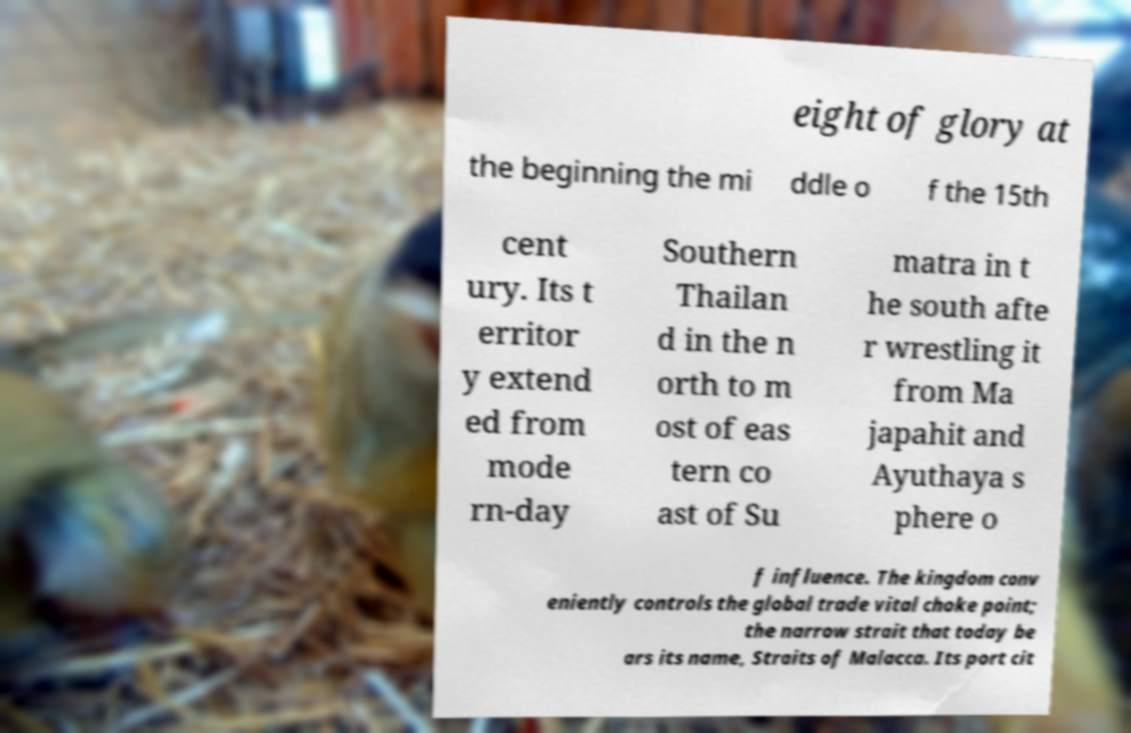Can you read and provide the text displayed in the image?This photo seems to have some interesting text. Can you extract and type it out for me? eight of glory at the beginning the mi ddle o f the 15th cent ury. Its t erritor y extend ed from mode rn-day Southern Thailan d in the n orth to m ost of eas tern co ast of Su matra in t he south afte r wrestling it from Ma japahit and Ayuthaya s phere o f influence. The kingdom conv eniently controls the global trade vital choke point; the narrow strait that today be ars its name, Straits of Malacca. Its port cit 